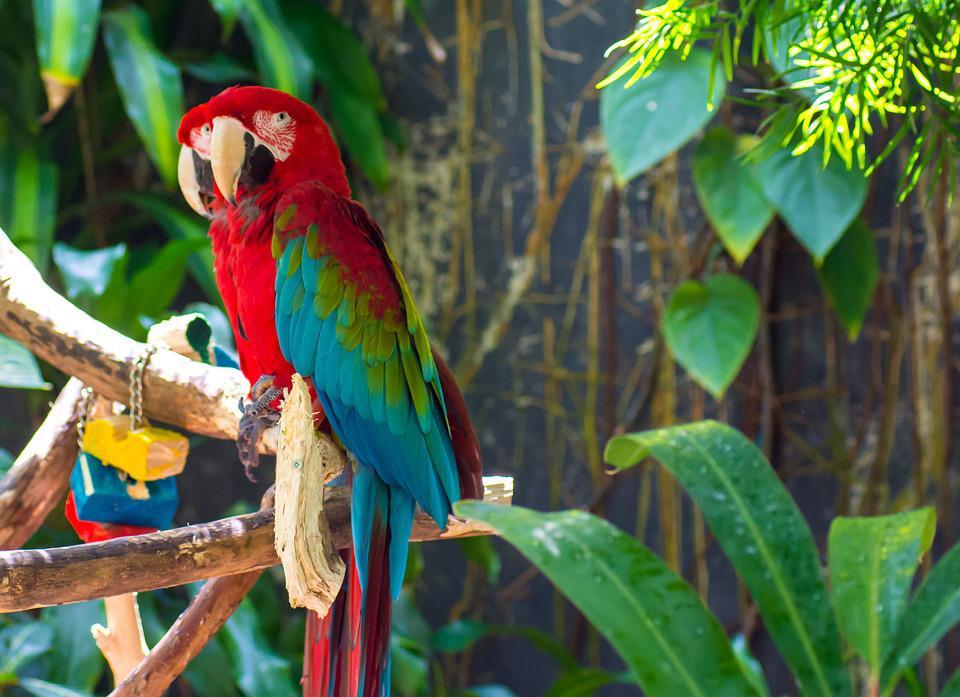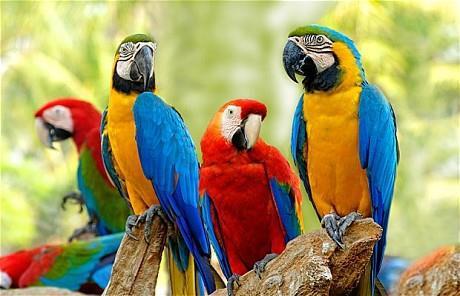The first image is the image on the left, the second image is the image on the right. Assess this claim about the two images: "The right image contains exactly two parrots.". Correct or not? Answer yes or no. No. The first image is the image on the left, the second image is the image on the right. Considering the images on both sides, is "The combined images contain no more than four parrots, and include a parrot with a green head and body." valid? Answer yes or no. No. 